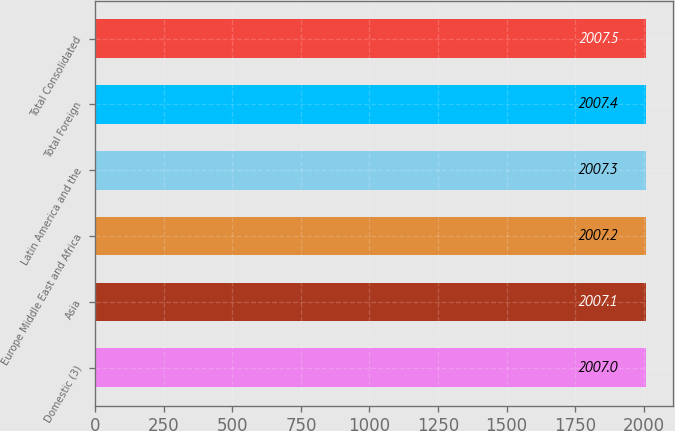Convert chart to OTSL. <chart><loc_0><loc_0><loc_500><loc_500><bar_chart><fcel>Domestic (3)<fcel>Asia<fcel>Europe Middle East and Africa<fcel>Latin America and the<fcel>Total Foreign<fcel>Total Consolidated<nl><fcel>2007<fcel>2007.1<fcel>2007.2<fcel>2007.3<fcel>2007.4<fcel>2007.5<nl></chart> 